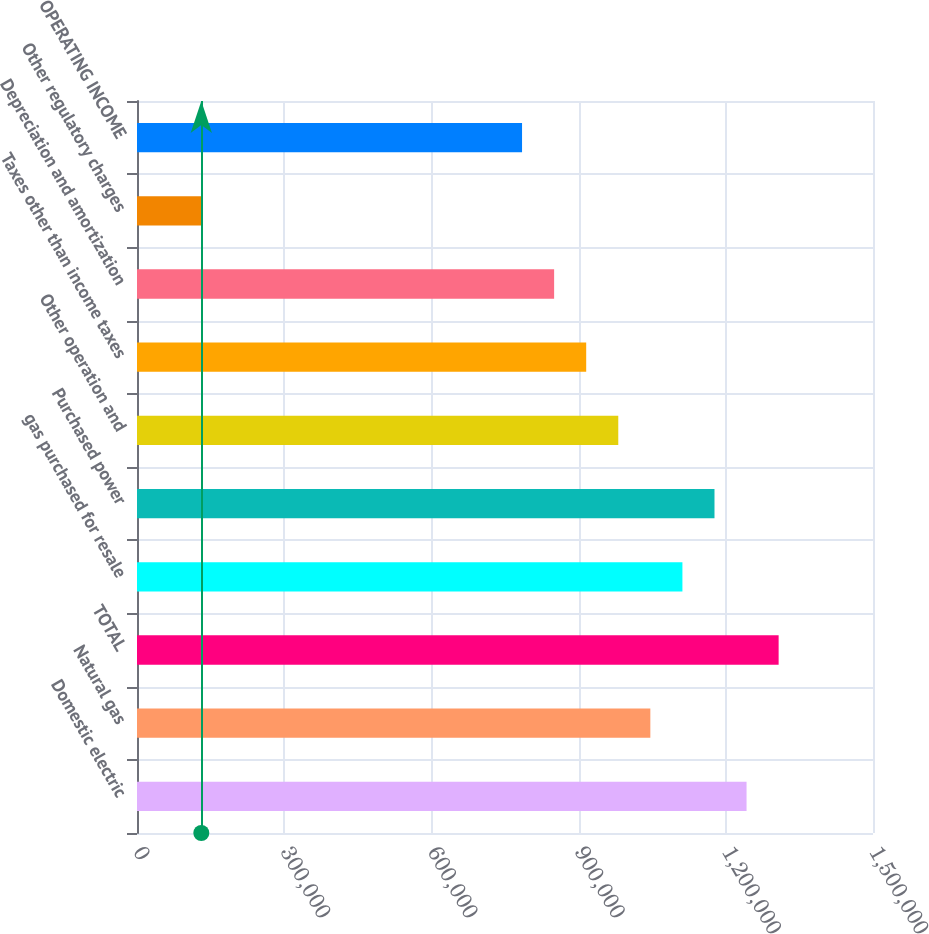<chart> <loc_0><loc_0><loc_500><loc_500><bar_chart><fcel>Domestic electric<fcel>Natural gas<fcel>TOTAL<fcel>gas purchased for resale<fcel>Purchased power<fcel>Other operation and<fcel>Taxes other than income taxes<fcel>Depreciation and amortization<fcel>Other regulatory charges<fcel>OPERATING INCOME<nl><fcel>1.24232e+06<fcel>1.04622e+06<fcel>1.30768e+06<fcel>1.11158e+06<fcel>1.17695e+06<fcel>980849<fcel>915482<fcel>850116<fcel>131083<fcel>784749<nl></chart> 